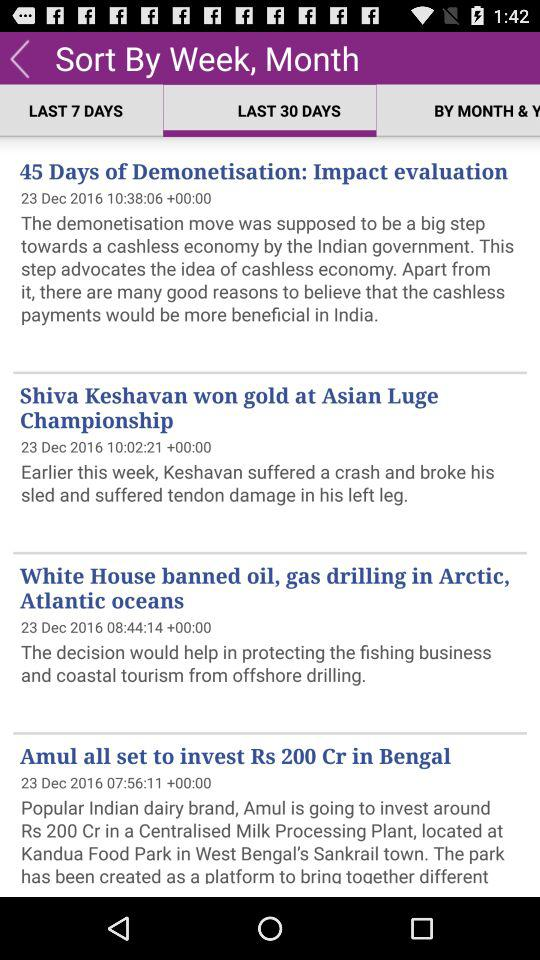Which option is selected? The selected option is "Last 30 Days". 